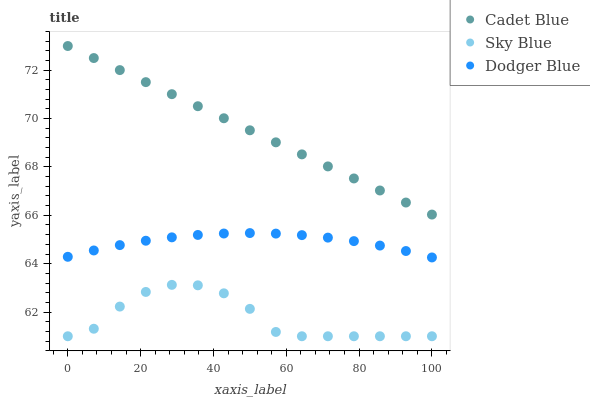Does Sky Blue have the minimum area under the curve?
Answer yes or no. Yes. Does Cadet Blue have the maximum area under the curve?
Answer yes or no. Yes. Does Dodger Blue have the minimum area under the curve?
Answer yes or no. No. Does Dodger Blue have the maximum area under the curve?
Answer yes or no. No. Is Cadet Blue the smoothest?
Answer yes or no. Yes. Is Sky Blue the roughest?
Answer yes or no. Yes. Is Dodger Blue the smoothest?
Answer yes or no. No. Is Dodger Blue the roughest?
Answer yes or no. No. Does Sky Blue have the lowest value?
Answer yes or no. Yes. Does Dodger Blue have the lowest value?
Answer yes or no. No. Does Cadet Blue have the highest value?
Answer yes or no. Yes. Does Dodger Blue have the highest value?
Answer yes or no. No. Is Dodger Blue less than Cadet Blue?
Answer yes or no. Yes. Is Dodger Blue greater than Sky Blue?
Answer yes or no. Yes. Does Dodger Blue intersect Cadet Blue?
Answer yes or no. No. 